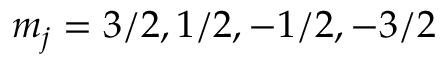Convert formula to latex. <formula><loc_0><loc_0><loc_500><loc_500>m _ { j } = 3 / 2 , 1 / 2 , - 1 / 2 , - 3 / 2</formula> 